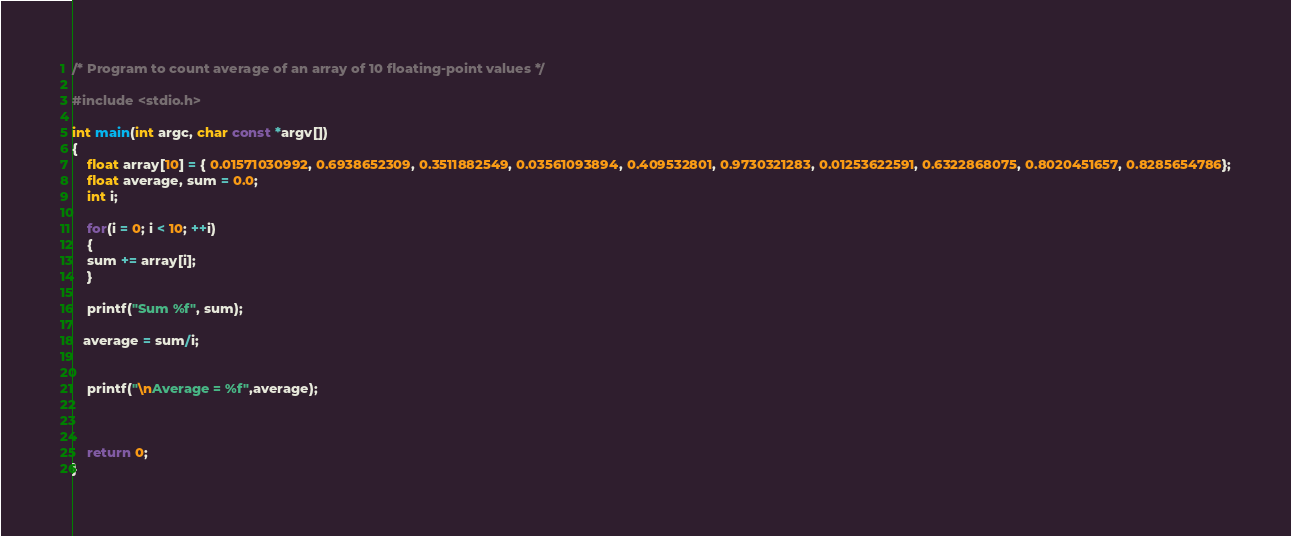<code> <loc_0><loc_0><loc_500><loc_500><_C_>/* Program to count average of an array of 10 floating-point values */

#include <stdio.h>

int main(int argc, char const *argv[])
{
    float array[10] = { 0.01571030992, 0.6938652309, 0.3511882549, 0.03561093894, 0.409532801, 0.9730321283, 0.01253622591, 0.6322868075, 0.8020451657, 0.8285654786};
    float average, sum = 0.0;
    int i;

    for(i = 0; i < 10; ++i)
    {
    sum += array[i];
    }

    printf("Sum %f", sum);
     
   average = sum/i;


    printf("\nAverage = %f",average);



    return 0;
}
</code> 